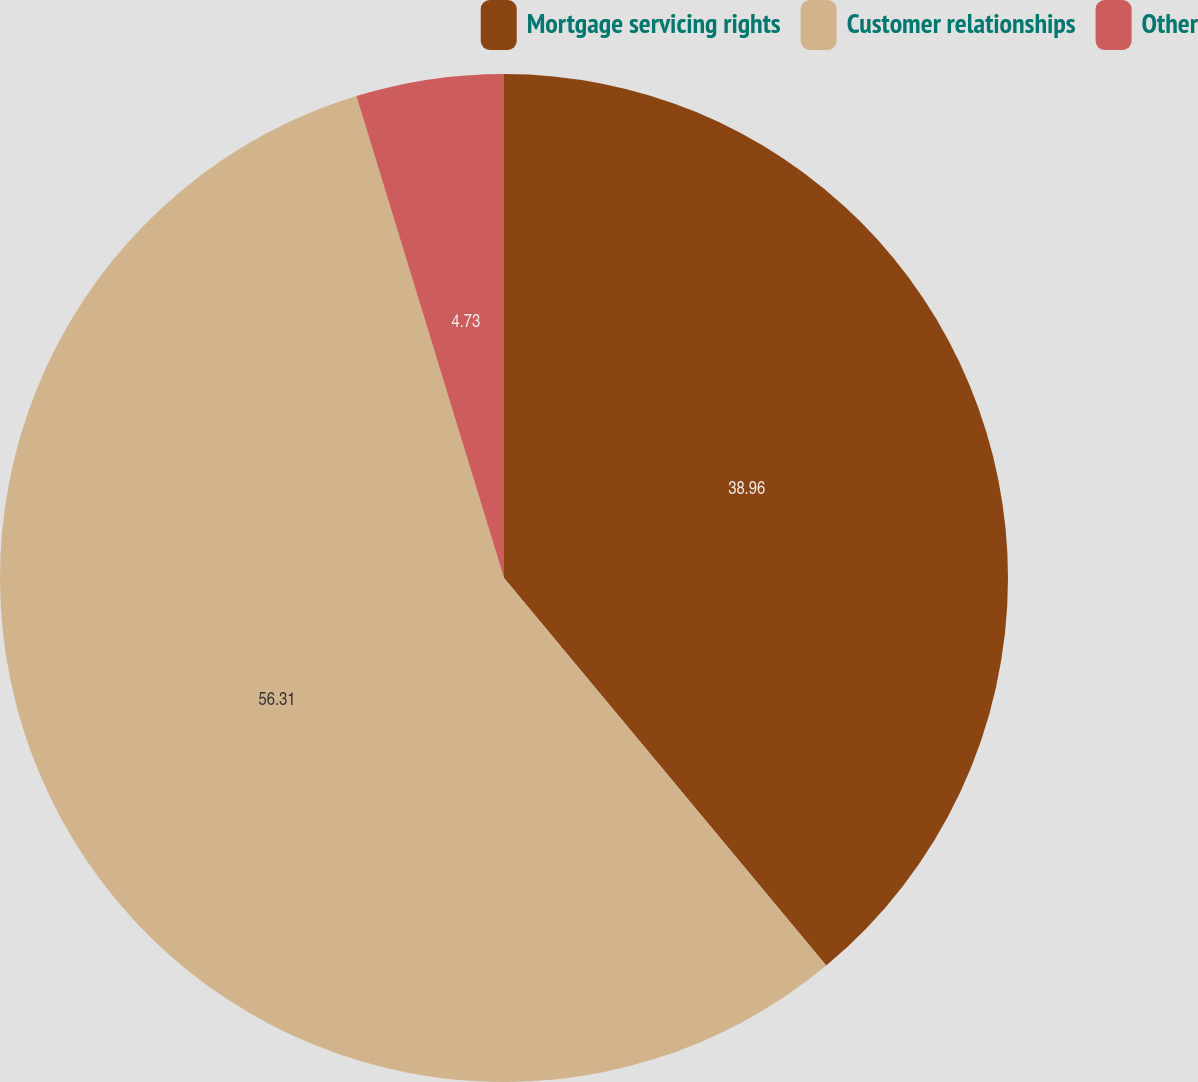<chart> <loc_0><loc_0><loc_500><loc_500><pie_chart><fcel>Mortgage servicing rights<fcel>Customer relationships<fcel>Other<nl><fcel>38.96%<fcel>56.31%<fcel>4.73%<nl></chart> 